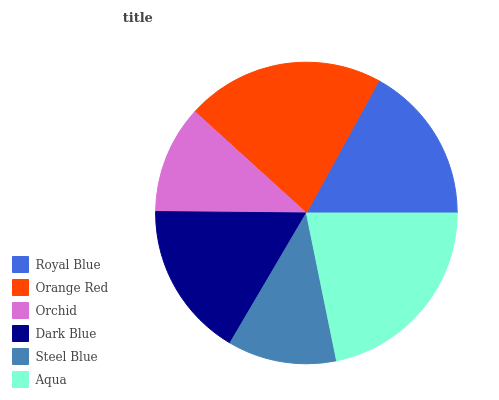Is Orchid the minimum?
Answer yes or no. Yes. Is Aqua the maximum?
Answer yes or no. Yes. Is Orange Red the minimum?
Answer yes or no. No. Is Orange Red the maximum?
Answer yes or no. No. Is Orange Red greater than Royal Blue?
Answer yes or no. Yes. Is Royal Blue less than Orange Red?
Answer yes or no. Yes. Is Royal Blue greater than Orange Red?
Answer yes or no. No. Is Orange Red less than Royal Blue?
Answer yes or no. No. Is Royal Blue the high median?
Answer yes or no. Yes. Is Dark Blue the low median?
Answer yes or no. Yes. Is Orange Red the high median?
Answer yes or no. No. Is Steel Blue the low median?
Answer yes or no. No. 